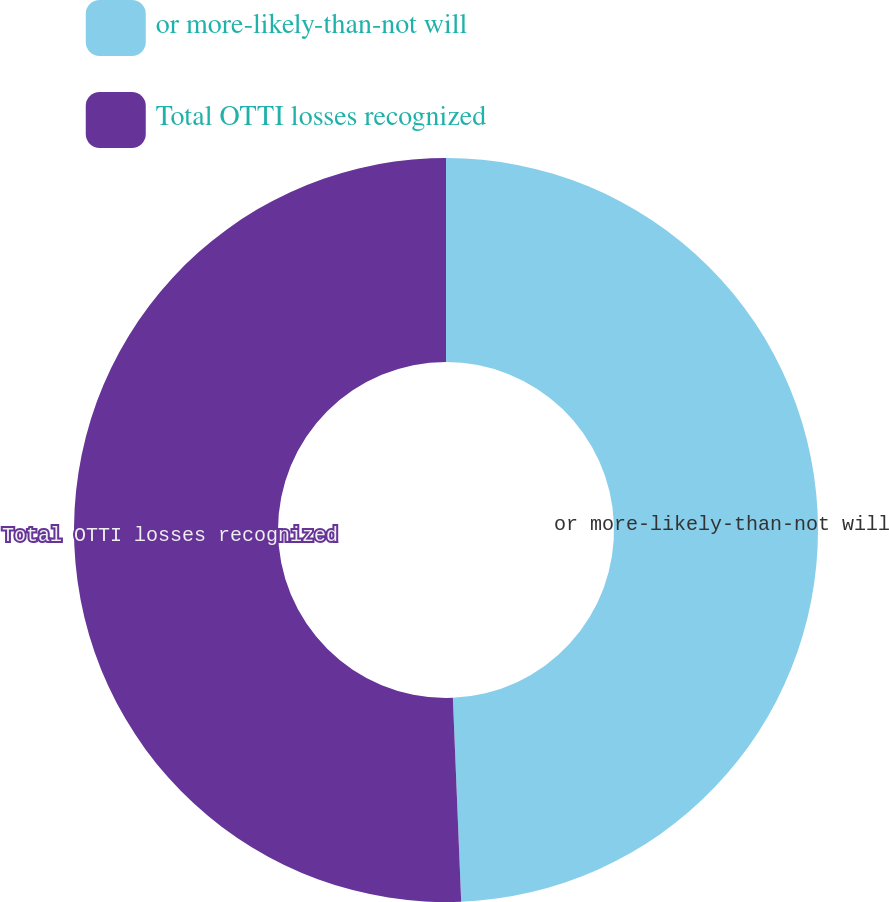Convert chart. <chart><loc_0><loc_0><loc_500><loc_500><pie_chart><fcel>or more-likely-than-not will<fcel>Total OTTI losses recognized<nl><fcel>49.35%<fcel>50.65%<nl></chart> 